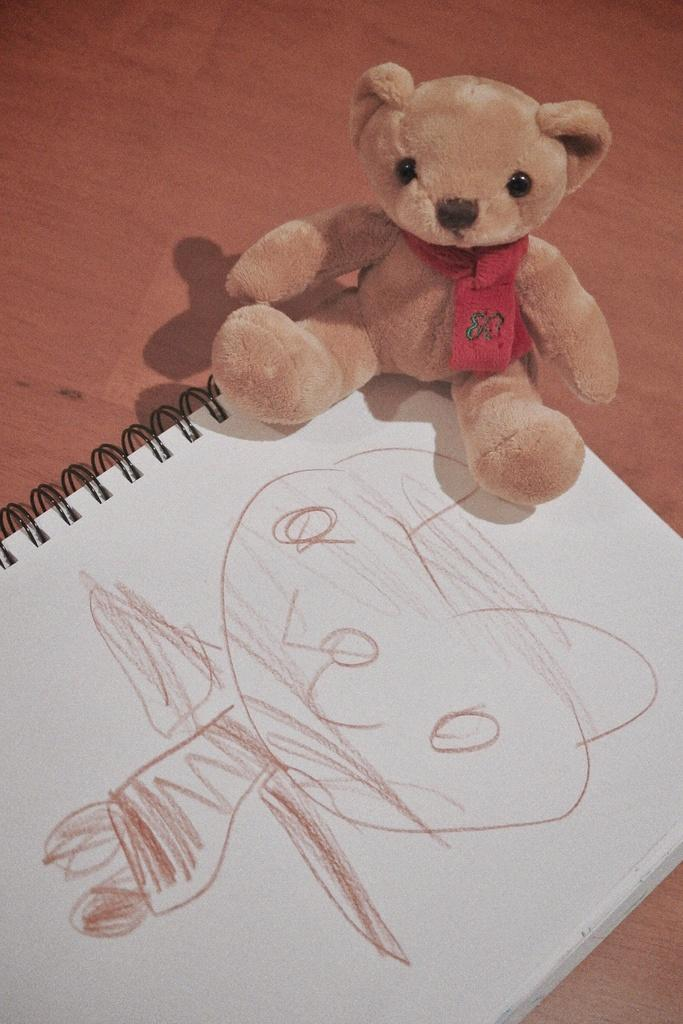What is the main object in the image? There is a teddy bear in the image. Where is the teddy bear located? The teddy bear is on a book. What is the book placed on? The book is placed on a table. What color is the cow's tail in the image? There is no cow present in the image, so it is not possible to determine the color of its tail. 